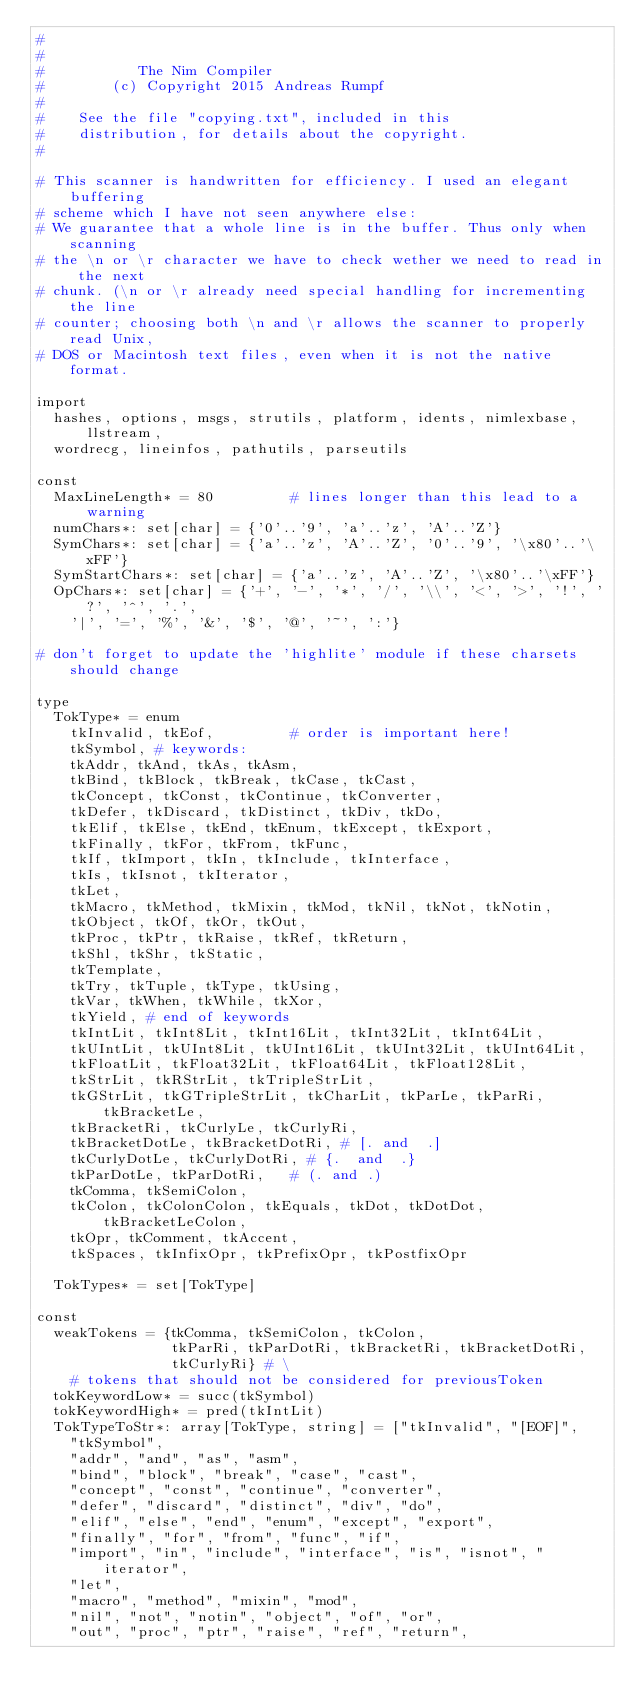Convert code to text. <code><loc_0><loc_0><loc_500><loc_500><_Nim_>#
#
#           The Nim Compiler
#        (c) Copyright 2015 Andreas Rumpf
#
#    See the file "copying.txt", included in this
#    distribution, for details about the copyright.
#

# This scanner is handwritten for efficiency. I used an elegant buffering
# scheme which I have not seen anywhere else:
# We guarantee that a whole line is in the buffer. Thus only when scanning
# the \n or \r character we have to check wether we need to read in the next
# chunk. (\n or \r already need special handling for incrementing the line
# counter; choosing both \n and \r allows the scanner to properly read Unix,
# DOS or Macintosh text files, even when it is not the native format.

import
  hashes, options, msgs, strutils, platform, idents, nimlexbase, llstream,
  wordrecg, lineinfos, pathutils, parseutils

const
  MaxLineLength* = 80         # lines longer than this lead to a warning
  numChars*: set[char] = {'0'..'9', 'a'..'z', 'A'..'Z'}
  SymChars*: set[char] = {'a'..'z', 'A'..'Z', '0'..'9', '\x80'..'\xFF'}
  SymStartChars*: set[char] = {'a'..'z', 'A'..'Z', '\x80'..'\xFF'}
  OpChars*: set[char] = {'+', '-', '*', '/', '\\', '<', '>', '!', '?', '^', '.',
    '|', '=', '%', '&', '$', '@', '~', ':'}

# don't forget to update the 'highlite' module if these charsets should change

type
  TokType* = enum
    tkInvalid, tkEof,         # order is important here!
    tkSymbol, # keywords:
    tkAddr, tkAnd, tkAs, tkAsm,
    tkBind, tkBlock, tkBreak, tkCase, tkCast,
    tkConcept, tkConst, tkContinue, tkConverter,
    tkDefer, tkDiscard, tkDistinct, tkDiv, tkDo,
    tkElif, tkElse, tkEnd, tkEnum, tkExcept, tkExport,
    tkFinally, tkFor, tkFrom, tkFunc,
    tkIf, tkImport, tkIn, tkInclude, tkInterface,
    tkIs, tkIsnot, tkIterator,
    tkLet,
    tkMacro, tkMethod, tkMixin, tkMod, tkNil, tkNot, tkNotin,
    tkObject, tkOf, tkOr, tkOut,
    tkProc, tkPtr, tkRaise, tkRef, tkReturn,
    tkShl, tkShr, tkStatic,
    tkTemplate,
    tkTry, tkTuple, tkType, tkUsing,
    tkVar, tkWhen, tkWhile, tkXor,
    tkYield, # end of keywords
    tkIntLit, tkInt8Lit, tkInt16Lit, tkInt32Lit, tkInt64Lit,
    tkUIntLit, tkUInt8Lit, tkUInt16Lit, tkUInt32Lit, tkUInt64Lit,
    tkFloatLit, tkFloat32Lit, tkFloat64Lit, tkFloat128Lit,
    tkStrLit, tkRStrLit, tkTripleStrLit,
    tkGStrLit, tkGTripleStrLit, tkCharLit, tkParLe, tkParRi, tkBracketLe,
    tkBracketRi, tkCurlyLe, tkCurlyRi,
    tkBracketDotLe, tkBracketDotRi, # [. and  .]
    tkCurlyDotLe, tkCurlyDotRi, # {.  and  .}
    tkParDotLe, tkParDotRi,   # (. and .)
    tkComma, tkSemiColon,
    tkColon, tkColonColon, tkEquals, tkDot, tkDotDot, tkBracketLeColon,
    tkOpr, tkComment, tkAccent,
    tkSpaces, tkInfixOpr, tkPrefixOpr, tkPostfixOpr

  TokTypes* = set[TokType]

const
  weakTokens = {tkComma, tkSemiColon, tkColon,
                tkParRi, tkParDotRi, tkBracketRi, tkBracketDotRi,
                tkCurlyRi} # \
    # tokens that should not be considered for previousToken
  tokKeywordLow* = succ(tkSymbol)
  tokKeywordHigh* = pred(tkIntLit)
  TokTypeToStr*: array[TokType, string] = ["tkInvalid", "[EOF]",
    "tkSymbol",
    "addr", "and", "as", "asm",
    "bind", "block", "break", "case", "cast",
    "concept", "const", "continue", "converter",
    "defer", "discard", "distinct", "div", "do",
    "elif", "else", "end", "enum", "except", "export",
    "finally", "for", "from", "func", "if",
    "import", "in", "include", "interface", "is", "isnot", "iterator",
    "let",
    "macro", "method", "mixin", "mod",
    "nil", "not", "notin", "object", "of", "or",
    "out", "proc", "ptr", "raise", "ref", "return",</code> 